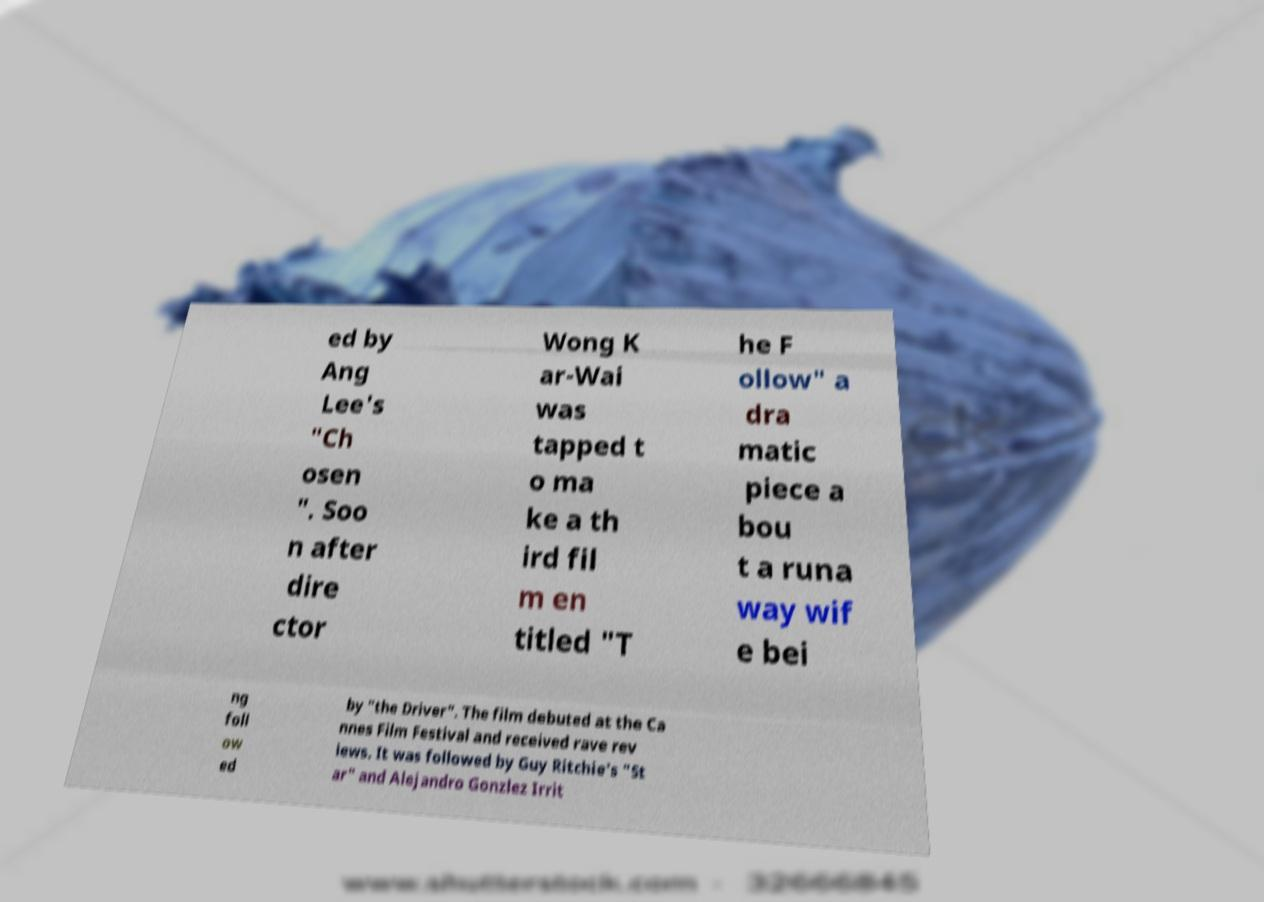What messages or text are displayed in this image? I need them in a readable, typed format. ed by Ang Lee's "Ch osen ". Soo n after dire ctor Wong K ar-Wai was tapped t o ma ke a th ird fil m en titled "T he F ollow" a dra matic piece a bou t a runa way wif e bei ng foll ow ed by "the Driver". The film debuted at the Ca nnes Film Festival and received rave rev iews. It was followed by Guy Ritchie's "St ar" and Alejandro Gonzlez Irrit 